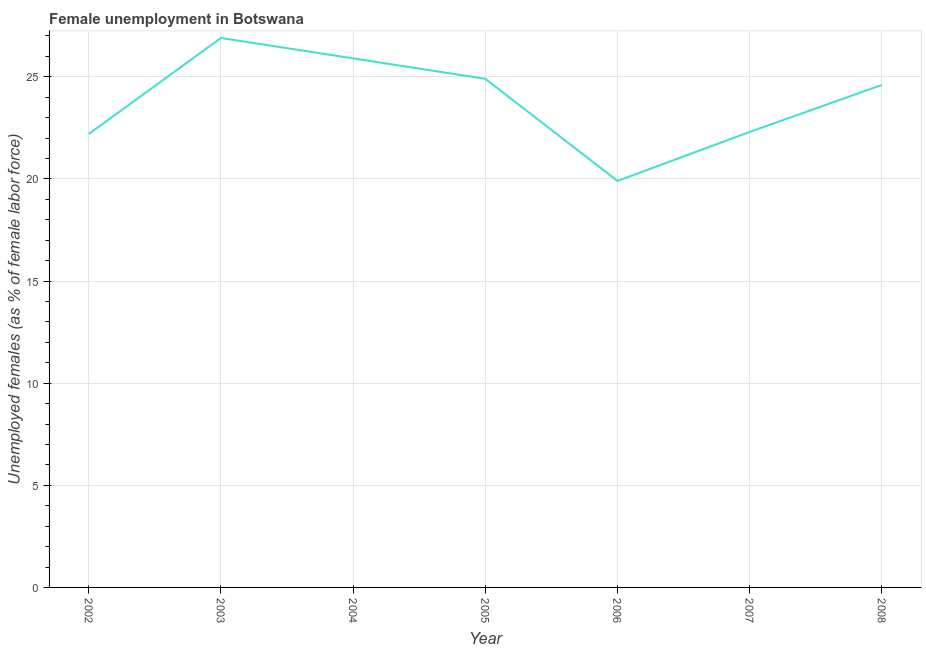What is the unemployed females population in 2003?
Make the answer very short. 26.9. Across all years, what is the maximum unemployed females population?
Offer a very short reply. 26.9. Across all years, what is the minimum unemployed females population?
Offer a very short reply. 19.9. In which year was the unemployed females population maximum?
Offer a very short reply. 2003. In which year was the unemployed females population minimum?
Ensure brevity in your answer.  2006. What is the sum of the unemployed females population?
Give a very brief answer. 166.7. What is the difference between the unemployed females population in 2004 and 2006?
Ensure brevity in your answer.  6. What is the average unemployed females population per year?
Your answer should be compact. 23.81. What is the median unemployed females population?
Give a very brief answer. 24.6. In how many years, is the unemployed females population greater than 19 %?
Give a very brief answer. 7. Do a majority of the years between 2002 and 2005 (inclusive) have unemployed females population greater than 26 %?
Provide a succinct answer. No. What is the ratio of the unemployed females population in 2005 to that in 2006?
Provide a short and direct response. 1.25. What is the difference between the highest and the second highest unemployed females population?
Your answer should be compact. 1. Is the sum of the unemployed females population in 2003 and 2004 greater than the maximum unemployed females population across all years?
Provide a succinct answer. Yes. What is the difference between the highest and the lowest unemployed females population?
Offer a very short reply. 7. How many years are there in the graph?
Provide a succinct answer. 7. What is the difference between two consecutive major ticks on the Y-axis?
Your response must be concise. 5. Does the graph contain any zero values?
Your response must be concise. No. What is the title of the graph?
Ensure brevity in your answer.  Female unemployment in Botswana. What is the label or title of the X-axis?
Your answer should be very brief. Year. What is the label or title of the Y-axis?
Keep it short and to the point. Unemployed females (as % of female labor force). What is the Unemployed females (as % of female labor force) in 2002?
Offer a very short reply. 22.2. What is the Unemployed females (as % of female labor force) of 2003?
Your answer should be compact. 26.9. What is the Unemployed females (as % of female labor force) of 2004?
Your answer should be very brief. 25.9. What is the Unemployed females (as % of female labor force) in 2005?
Your answer should be very brief. 24.9. What is the Unemployed females (as % of female labor force) in 2006?
Offer a very short reply. 19.9. What is the Unemployed females (as % of female labor force) of 2007?
Your answer should be very brief. 22.3. What is the Unemployed females (as % of female labor force) in 2008?
Offer a terse response. 24.6. What is the difference between the Unemployed females (as % of female labor force) in 2002 and 2003?
Offer a terse response. -4.7. What is the difference between the Unemployed females (as % of female labor force) in 2002 and 2005?
Offer a terse response. -2.7. What is the difference between the Unemployed females (as % of female labor force) in 2002 and 2006?
Give a very brief answer. 2.3. What is the difference between the Unemployed females (as % of female labor force) in 2002 and 2008?
Provide a short and direct response. -2.4. What is the difference between the Unemployed females (as % of female labor force) in 2003 and 2004?
Keep it short and to the point. 1. What is the difference between the Unemployed females (as % of female labor force) in 2003 and 2005?
Offer a very short reply. 2. What is the difference between the Unemployed females (as % of female labor force) in 2003 and 2006?
Provide a succinct answer. 7. What is the difference between the Unemployed females (as % of female labor force) in 2003 and 2007?
Your answer should be compact. 4.6. What is the difference between the Unemployed females (as % of female labor force) in 2004 and 2006?
Offer a very short reply. 6. What is the difference between the Unemployed females (as % of female labor force) in 2004 and 2007?
Give a very brief answer. 3.6. What is the difference between the Unemployed females (as % of female labor force) in 2004 and 2008?
Your answer should be compact. 1.3. What is the difference between the Unemployed females (as % of female labor force) in 2005 and 2006?
Keep it short and to the point. 5. What is the difference between the Unemployed females (as % of female labor force) in 2005 and 2008?
Your answer should be very brief. 0.3. What is the difference between the Unemployed females (as % of female labor force) in 2006 and 2007?
Keep it short and to the point. -2.4. What is the difference between the Unemployed females (as % of female labor force) in 2007 and 2008?
Your answer should be compact. -2.3. What is the ratio of the Unemployed females (as % of female labor force) in 2002 to that in 2003?
Offer a terse response. 0.82. What is the ratio of the Unemployed females (as % of female labor force) in 2002 to that in 2004?
Provide a short and direct response. 0.86. What is the ratio of the Unemployed females (as % of female labor force) in 2002 to that in 2005?
Your answer should be compact. 0.89. What is the ratio of the Unemployed females (as % of female labor force) in 2002 to that in 2006?
Provide a succinct answer. 1.12. What is the ratio of the Unemployed females (as % of female labor force) in 2002 to that in 2007?
Your answer should be compact. 1. What is the ratio of the Unemployed females (as % of female labor force) in 2002 to that in 2008?
Keep it short and to the point. 0.9. What is the ratio of the Unemployed females (as % of female labor force) in 2003 to that in 2004?
Give a very brief answer. 1.04. What is the ratio of the Unemployed females (as % of female labor force) in 2003 to that in 2006?
Ensure brevity in your answer.  1.35. What is the ratio of the Unemployed females (as % of female labor force) in 2003 to that in 2007?
Ensure brevity in your answer.  1.21. What is the ratio of the Unemployed females (as % of female labor force) in 2003 to that in 2008?
Your response must be concise. 1.09. What is the ratio of the Unemployed females (as % of female labor force) in 2004 to that in 2005?
Your answer should be compact. 1.04. What is the ratio of the Unemployed females (as % of female labor force) in 2004 to that in 2006?
Provide a short and direct response. 1.3. What is the ratio of the Unemployed females (as % of female labor force) in 2004 to that in 2007?
Give a very brief answer. 1.16. What is the ratio of the Unemployed females (as % of female labor force) in 2004 to that in 2008?
Your answer should be very brief. 1.05. What is the ratio of the Unemployed females (as % of female labor force) in 2005 to that in 2006?
Provide a short and direct response. 1.25. What is the ratio of the Unemployed females (as % of female labor force) in 2005 to that in 2007?
Give a very brief answer. 1.12. What is the ratio of the Unemployed females (as % of female labor force) in 2006 to that in 2007?
Keep it short and to the point. 0.89. What is the ratio of the Unemployed females (as % of female labor force) in 2006 to that in 2008?
Provide a short and direct response. 0.81. What is the ratio of the Unemployed females (as % of female labor force) in 2007 to that in 2008?
Offer a very short reply. 0.91. 